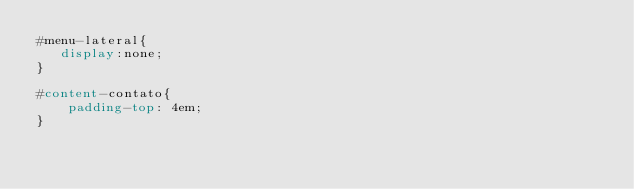Convert code to text. <code><loc_0><loc_0><loc_500><loc_500><_CSS_>#menu-lateral{
   display:none;
}
 
#content-contato{
    padding-top: 4em;
}</code> 